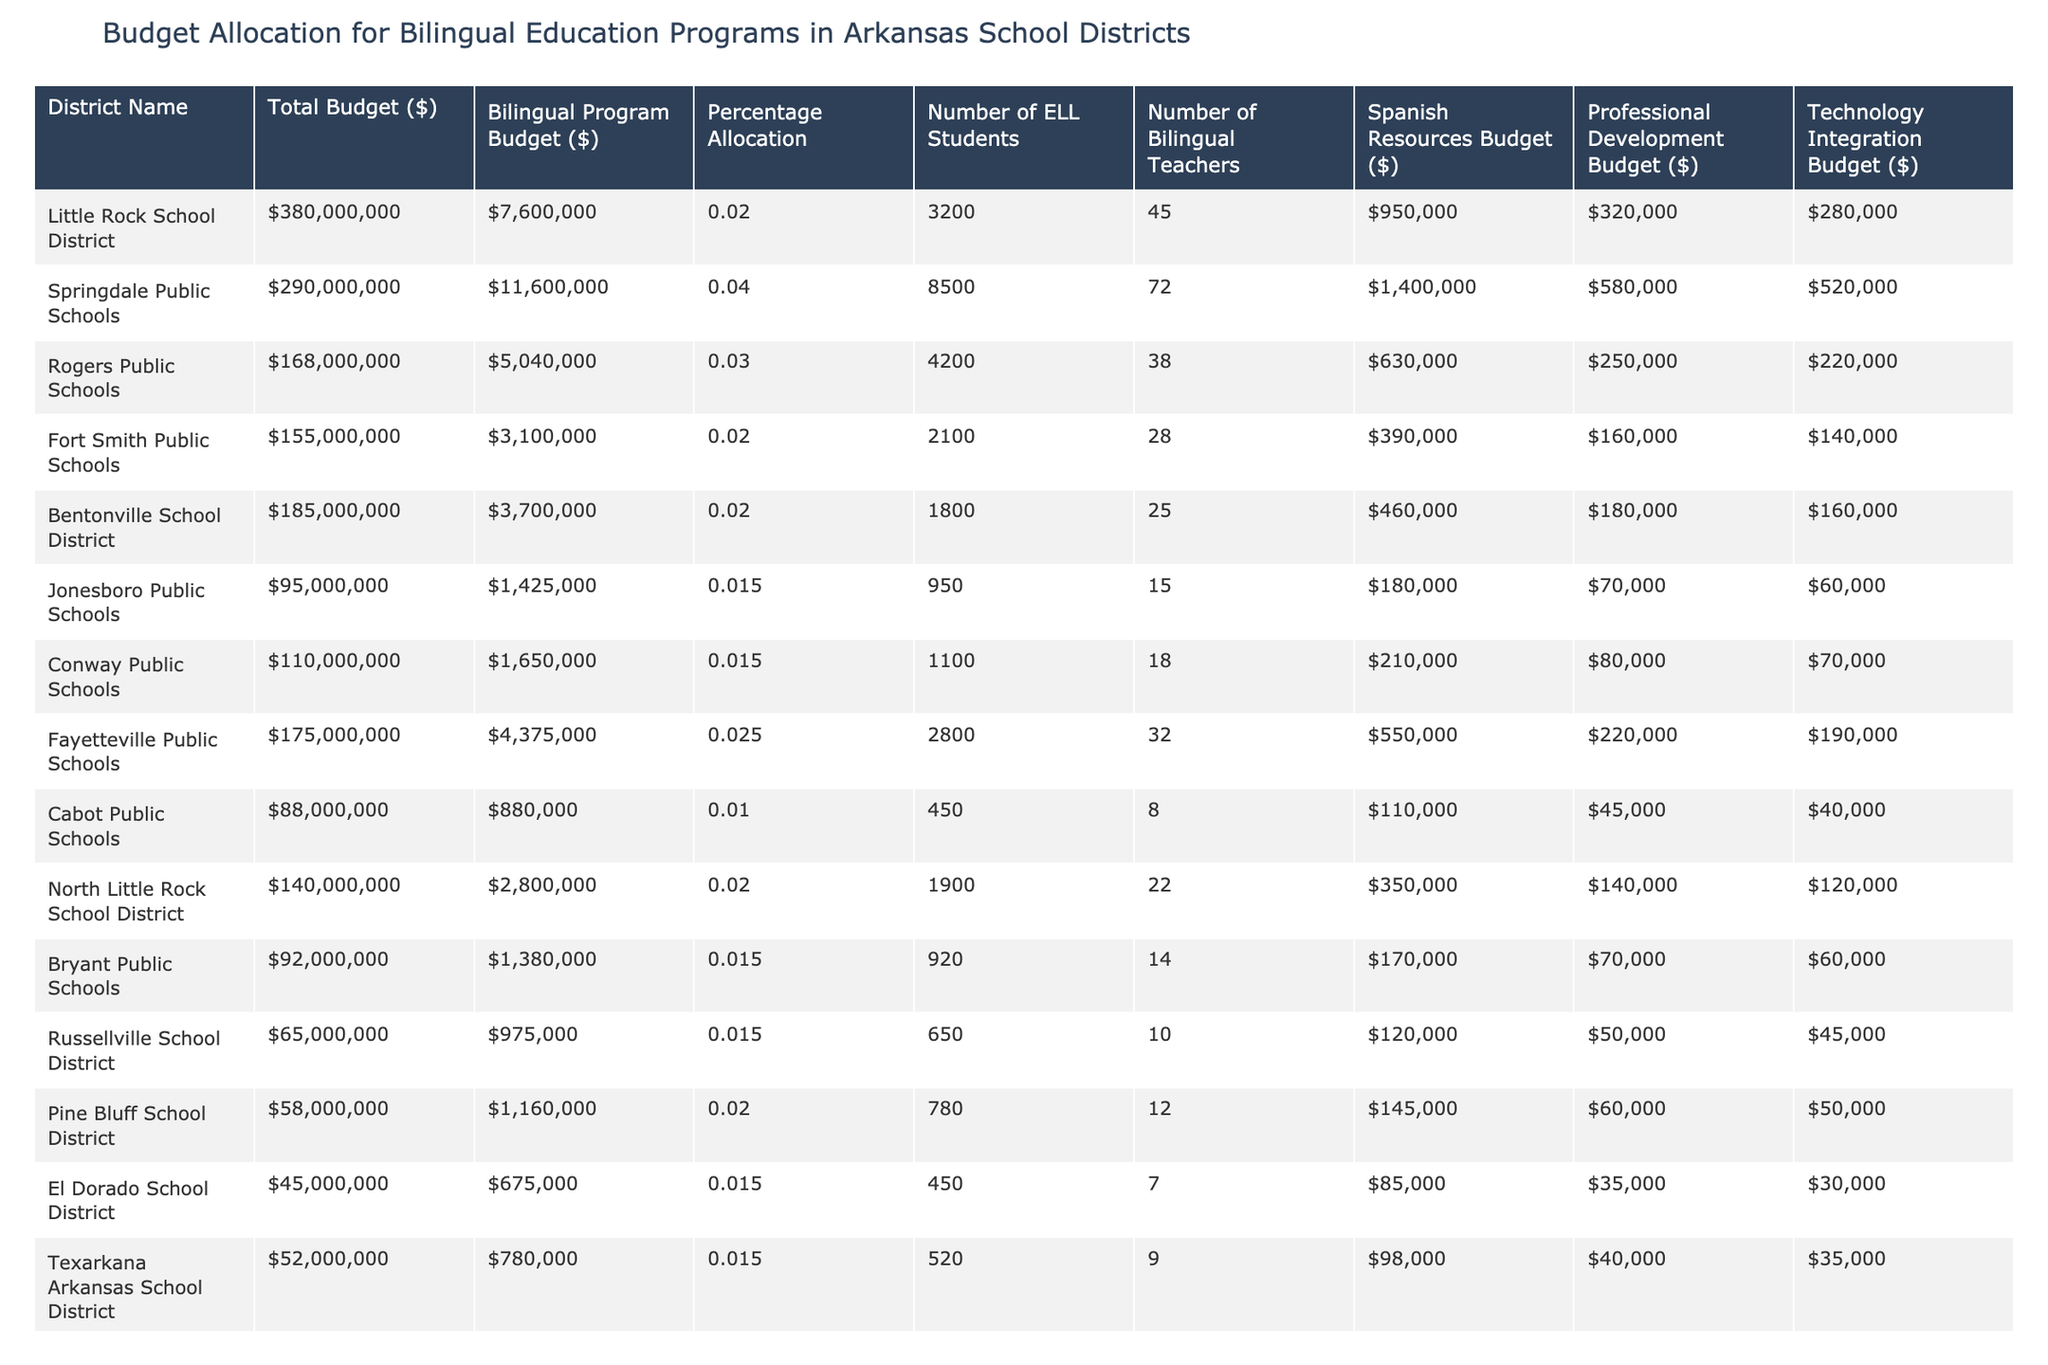What is the total budget for the Little Rock School District? The table directly states that the total budget for the Little Rock School District is $380,000,000.
Answer: $380,000,000 How many bilingual teachers are in Springdale Public Schools? According to the table, Springdale Public Schools has 72 bilingual teachers listed.
Answer: 72 What percentage of the budget is allocated to the bilingual program in Rogers Public Schools? The table shows that Rogers Public Schools allocates 3.00% of its total budget to the bilingual program.
Answer: 3.00% Which school district has the highest bilingual program budget? By comparing the bilingual program budgets in the table, Springdale Public Schools has the highest budget at $11,600,000.
Answer: Springdale Public Schools How much is allocated for professional development in the Fayetteville Public Schools? The table indicates that Fayetteville Public Schools has a professional development budget of $220,000.
Answer: $220,000 What is the average percentage allocation for bilingual programs across all listed districts? We sum up the percentage allocations (2.00 + 4.00 + 3.00 + 2.00 + 2.00 + 1.50 + 1.50 + 2.50 + 1.00 + 2.00 + 1.50 + 1.50) which equals 22.00%. Then, we divide by the number of districts (12) to find the average: 22.00% / 12 = 1.83%.
Answer: 1.83% Do any school districts have a bilingual program budget less than $1,000,000? The table shows that both Cabot Public Schools and El Dorado School District have bilingual program budgets of $880,000 and $675,000 respectively, indicating there are indeed districts that have budgets below $1,000,000.
Answer: Yes How does the technology integration budget of North Little Rock School District compare to that of Bentonville School District? The technology integration budget for North Little Rock School District is $120,000, whereas Bentonville School District's budget is $160,000. Since $120,000 is less than $160,000, North Little Rock has a lower budget.
Answer: North Little Rock has a lower budget What is the total number of ELL students across all listed districts? We sum the number of ELL students for each district: 3200 + 8500 + 4200 + 2100 + 1800 + 950 + 1100 + 2800 + 450 + 1900 + 920 + 650 + 780 + 520 = 19,770.
Answer: 19,770 Which school district has the lowest total budget, and what is that amount? The table reveals that the El Dorado School District has the lowest total budget at $45,000,000.
Answer: El Dorado School District, $45,000,000 